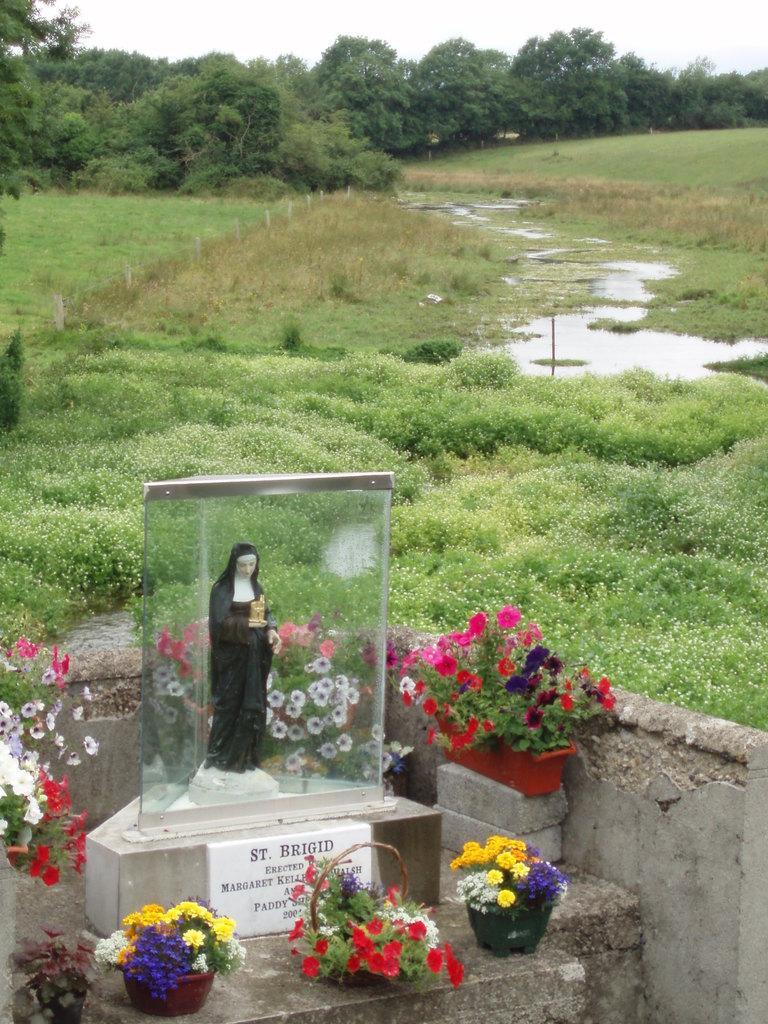In one or two sentences, can you explain what this image depicts? In this image there is a statue surrounded by a glass wall on the rock structure with some text and around the statue there are flower pots. In the background there is a grass, in the middle of the grass there are water, trees and a sky. 